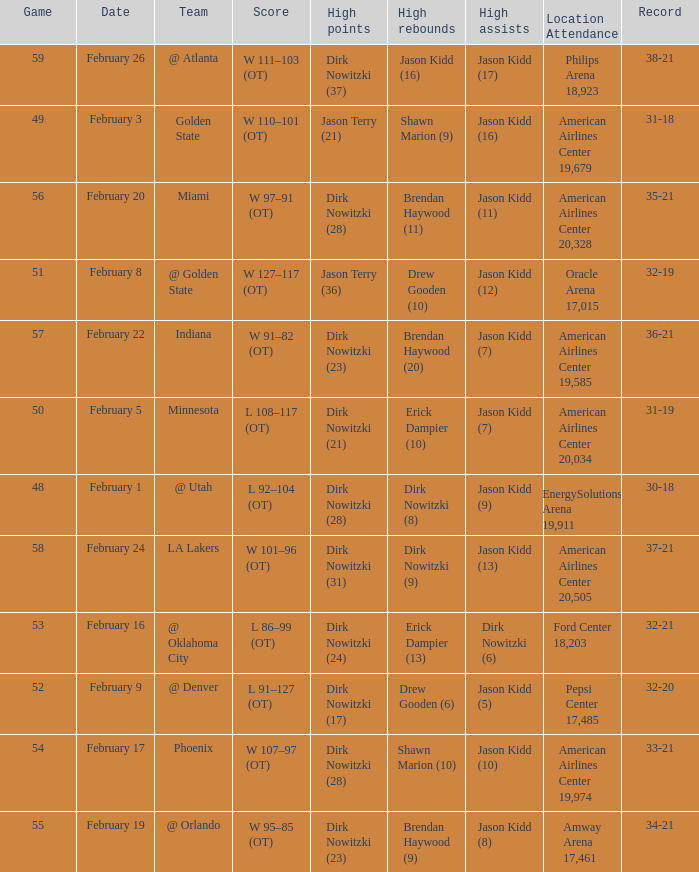When did the Mavericks have a record of 32-19? February 8. 